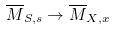Convert formula to latex. <formula><loc_0><loc_0><loc_500><loc_500>\overline { M } _ { S , s } \to \overline { M } _ { X , x }</formula> 